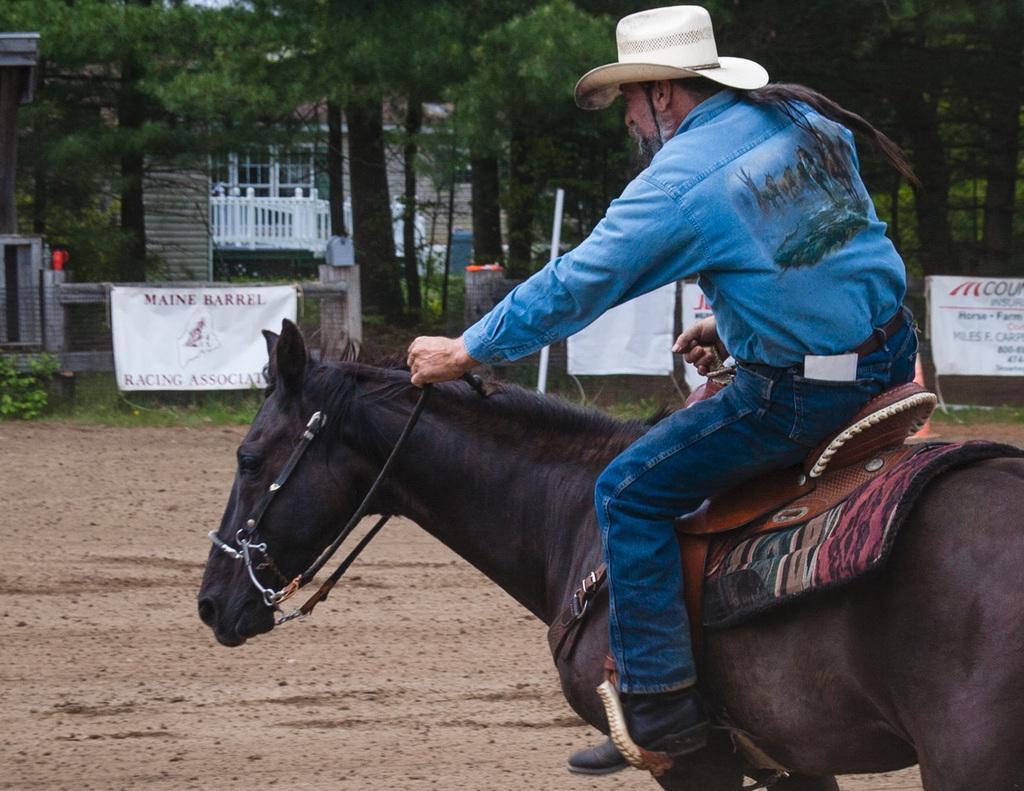Could you give a brief overview of what you see in this image? In this image, I can see the man riding the horse. These are the banners. I can see the trees. In the background, that looks like a building with the windows. 